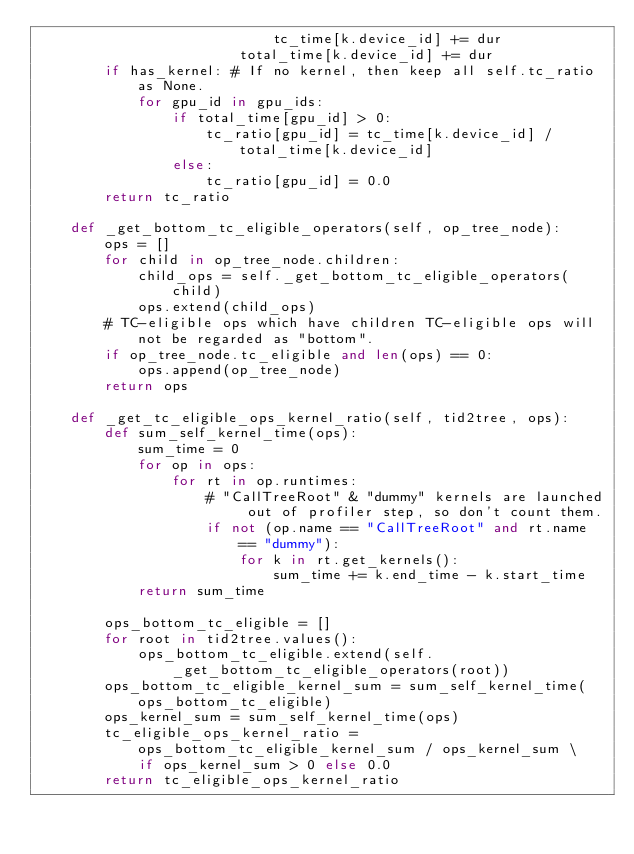Convert code to text. <code><loc_0><loc_0><loc_500><loc_500><_Python_>                            tc_time[k.device_id] += dur
                        total_time[k.device_id] += dur
        if has_kernel: # If no kernel, then keep all self.tc_ratio as None.
            for gpu_id in gpu_ids:
                if total_time[gpu_id] > 0:
                    tc_ratio[gpu_id] = tc_time[k.device_id] / total_time[k.device_id]
                else:
                    tc_ratio[gpu_id] = 0.0
        return tc_ratio

    def _get_bottom_tc_eligible_operators(self, op_tree_node):
        ops = []
        for child in op_tree_node.children:
            child_ops = self._get_bottom_tc_eligible_operators(child)
            ops.extend(child_ops)
        # TC-eligible ops which have children TC-eligible ops will not be regarded as "bottom".
        if op_tree_node.tc_eligible and len(ops) == 0:
            ops.append(op_tree_node)
        return ops

    def _get_tc_eligible_ops_kernel_ratio(self, tid2tree, ops):
        def sum_self_kernel_time(ops):
            sum_time = 0
            for op in ops:
                for rt in op.runtimes:
                    # "CallTreeRoot" & "dummy" kernels are launched out of profiler step, so don't count them.
                    if not (op.name == "CallTreeRoot" and rt.name == "dummy"):
                        for k in rt.get_kernels():
                            sum_time += k.end_time - k.start_time
            return sum_time

        ops_bottom_tc_eligible = []
        for root in tid2tree.values():
            ops_bottom_tc_eligible.extend(self._get_bottom_tc_eligible_operators(root))
        ops_bottom_tc_eligible_kernel_sum = sum_self_kernel_time(ops_bottom_tc_eligible)
        ops_kernel_sum = sum_self_kernel_time(ops)
        tc_eligible_ops_kernel_ratio = ops_bottom_tc_eligible_kernel_sum / ops_kernel_sum \
            if ops_kernel_sum > 0 else 0.0
        return tc_eligible_ops_kernel_ratio
</code> 